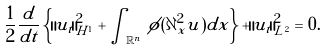Convert formula to latex. <formula><loc_0><loc_0><loc_500><loc_500>\frac { 1 } { 2 } \frac { d } { d t } \left \{ \| u _ { t } \| _ { H ^ { 1 } } ^ { 2 } + \int _ { \mathbb { R } ^ { n } } \, \phi ( \partial _ { x } ^ { 2 } u ) d x \right \} + \| u _ { t } \| _ { L ^ { 2 } } ^ { 2 } = 0 .</formula> 